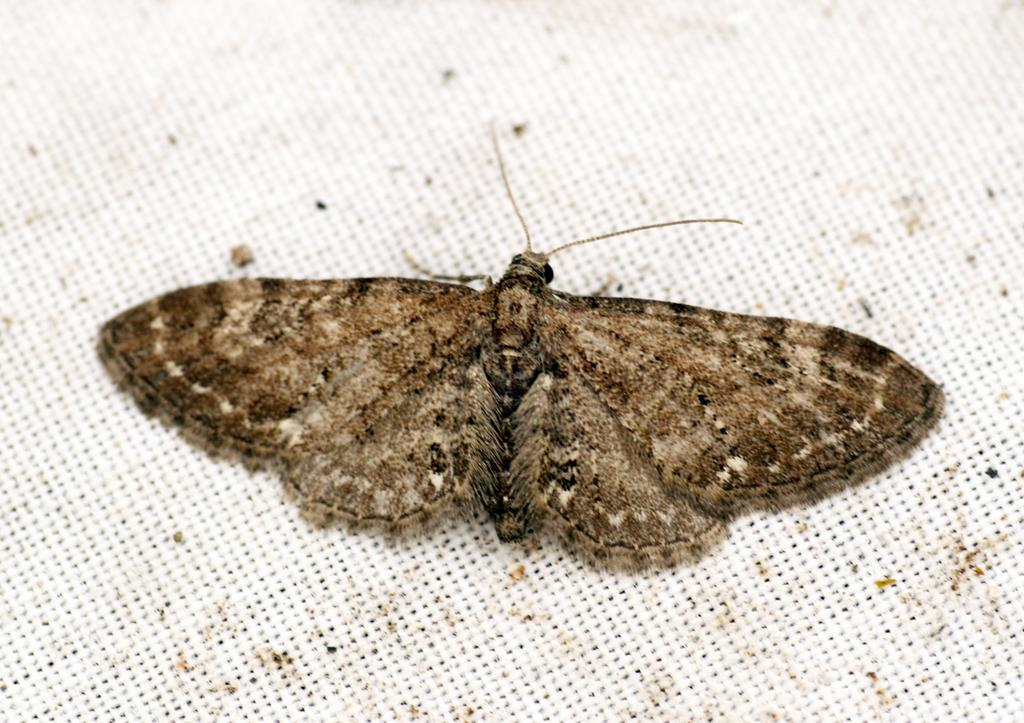What is the main subject of the picture? The main subject of the picture is a butterfly. Where is the butterfly located in the image? The butterfly is on an object. What type of bed can be seen in the image? There is no bed present in the image; it features a butterfly on an object. What kind of coil is visible in the image? There is no coil present in the image; it features a butterfly on an object. 